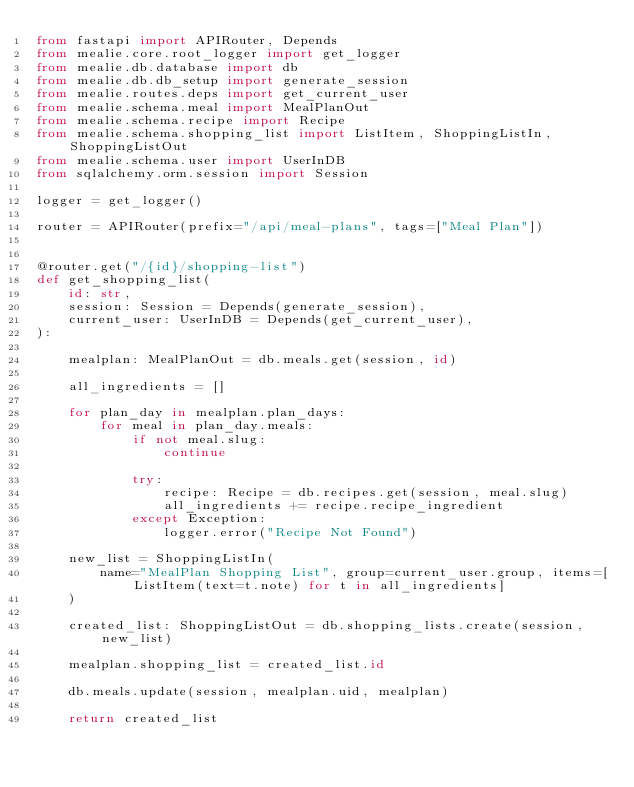<code> <loc_0><loc_0><loc_500><loc_500><_Python_>from fastapi import APIRouter, Depends
from mealie.core.root_logger import get_logger
from mealie.db.database import db
from mealie.db.db_setup import generate_session
from mealie.routes.deps import get_current_user
from mealie.schema.meal import MealPlanOut
from mealie.schema.recipe import Recipe
from mealie.schema.shopping_list import ListItem, ShoppingListIn, ShoppingListOut
from mealie.schema.user import UserInDB
from sqlalchemy.orm.session import Session

logger = get_logger()

router = APIRouter(prefix="/api/meal-plans", tags=["Meal Plan"])


@router.get("/{id}/shopping-list")
def get_shopping_list(
    id: str,
    session: Session = Depends(generate_session),
    current_user: UserInDB = Depends(get_current_user),
):

    mealplan: MealPlanOut = db.meals.get(session, id)

    all_ingredients = []

    for plan_day in mealplan.plan_days:
        for meal in plan_day.meals:
            if not meal.slug:
                continue

            try:
                recipe: Recipe = db.recipes.get(session, meal.slug)
                all_ingredients += recipe.recipe_ingredient
            except Exception:
                logger.error("Recipe Not Found")

    new_list = ShoppingListIn(
        name="MealPlan Shopping List", group=current_user.group, items=[ListItem(text=t.note) for t in all_ingredients]
    )

    created_list: ShoppingListOut = db.shopping_lists.create(session, new_list)

    mealplan.shopping_list = created_list.id

    db.meals.update(session, mealplan.uid, mealplan)

    return created_list
</code> 